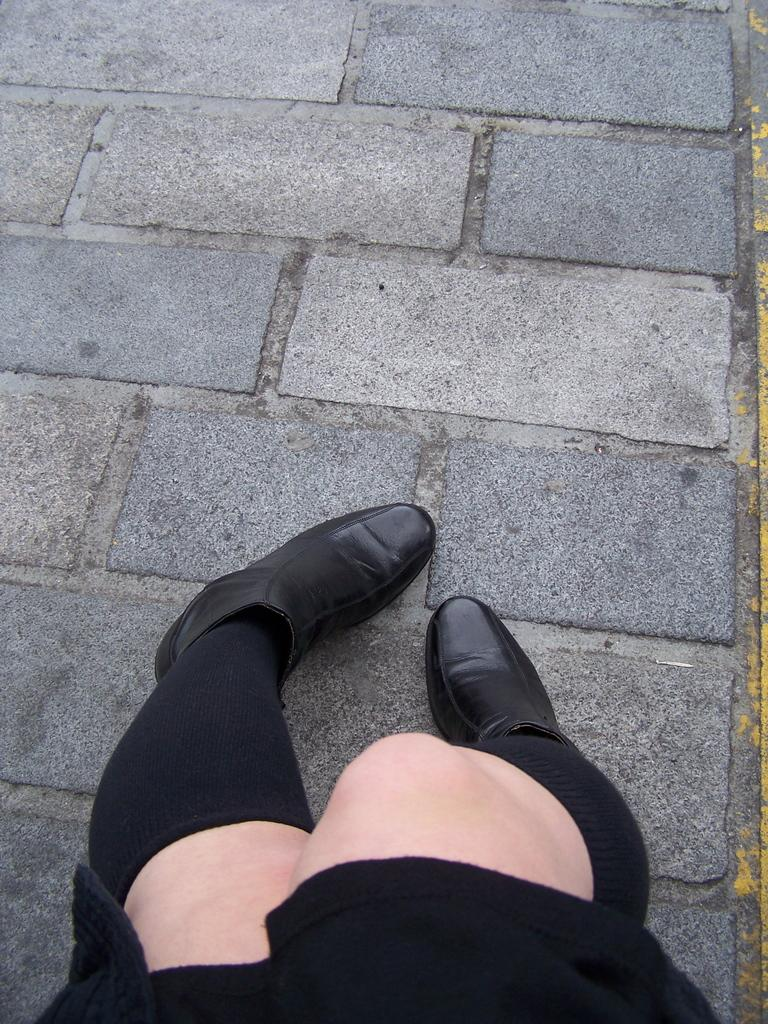What is visible in the foreground of the image? There are two legs of a woman in the foreground area of the image. How much money is the woman holding in the image? There is no indication of money or any financial transaction in the image. The image only shows the two legs of a woman. 